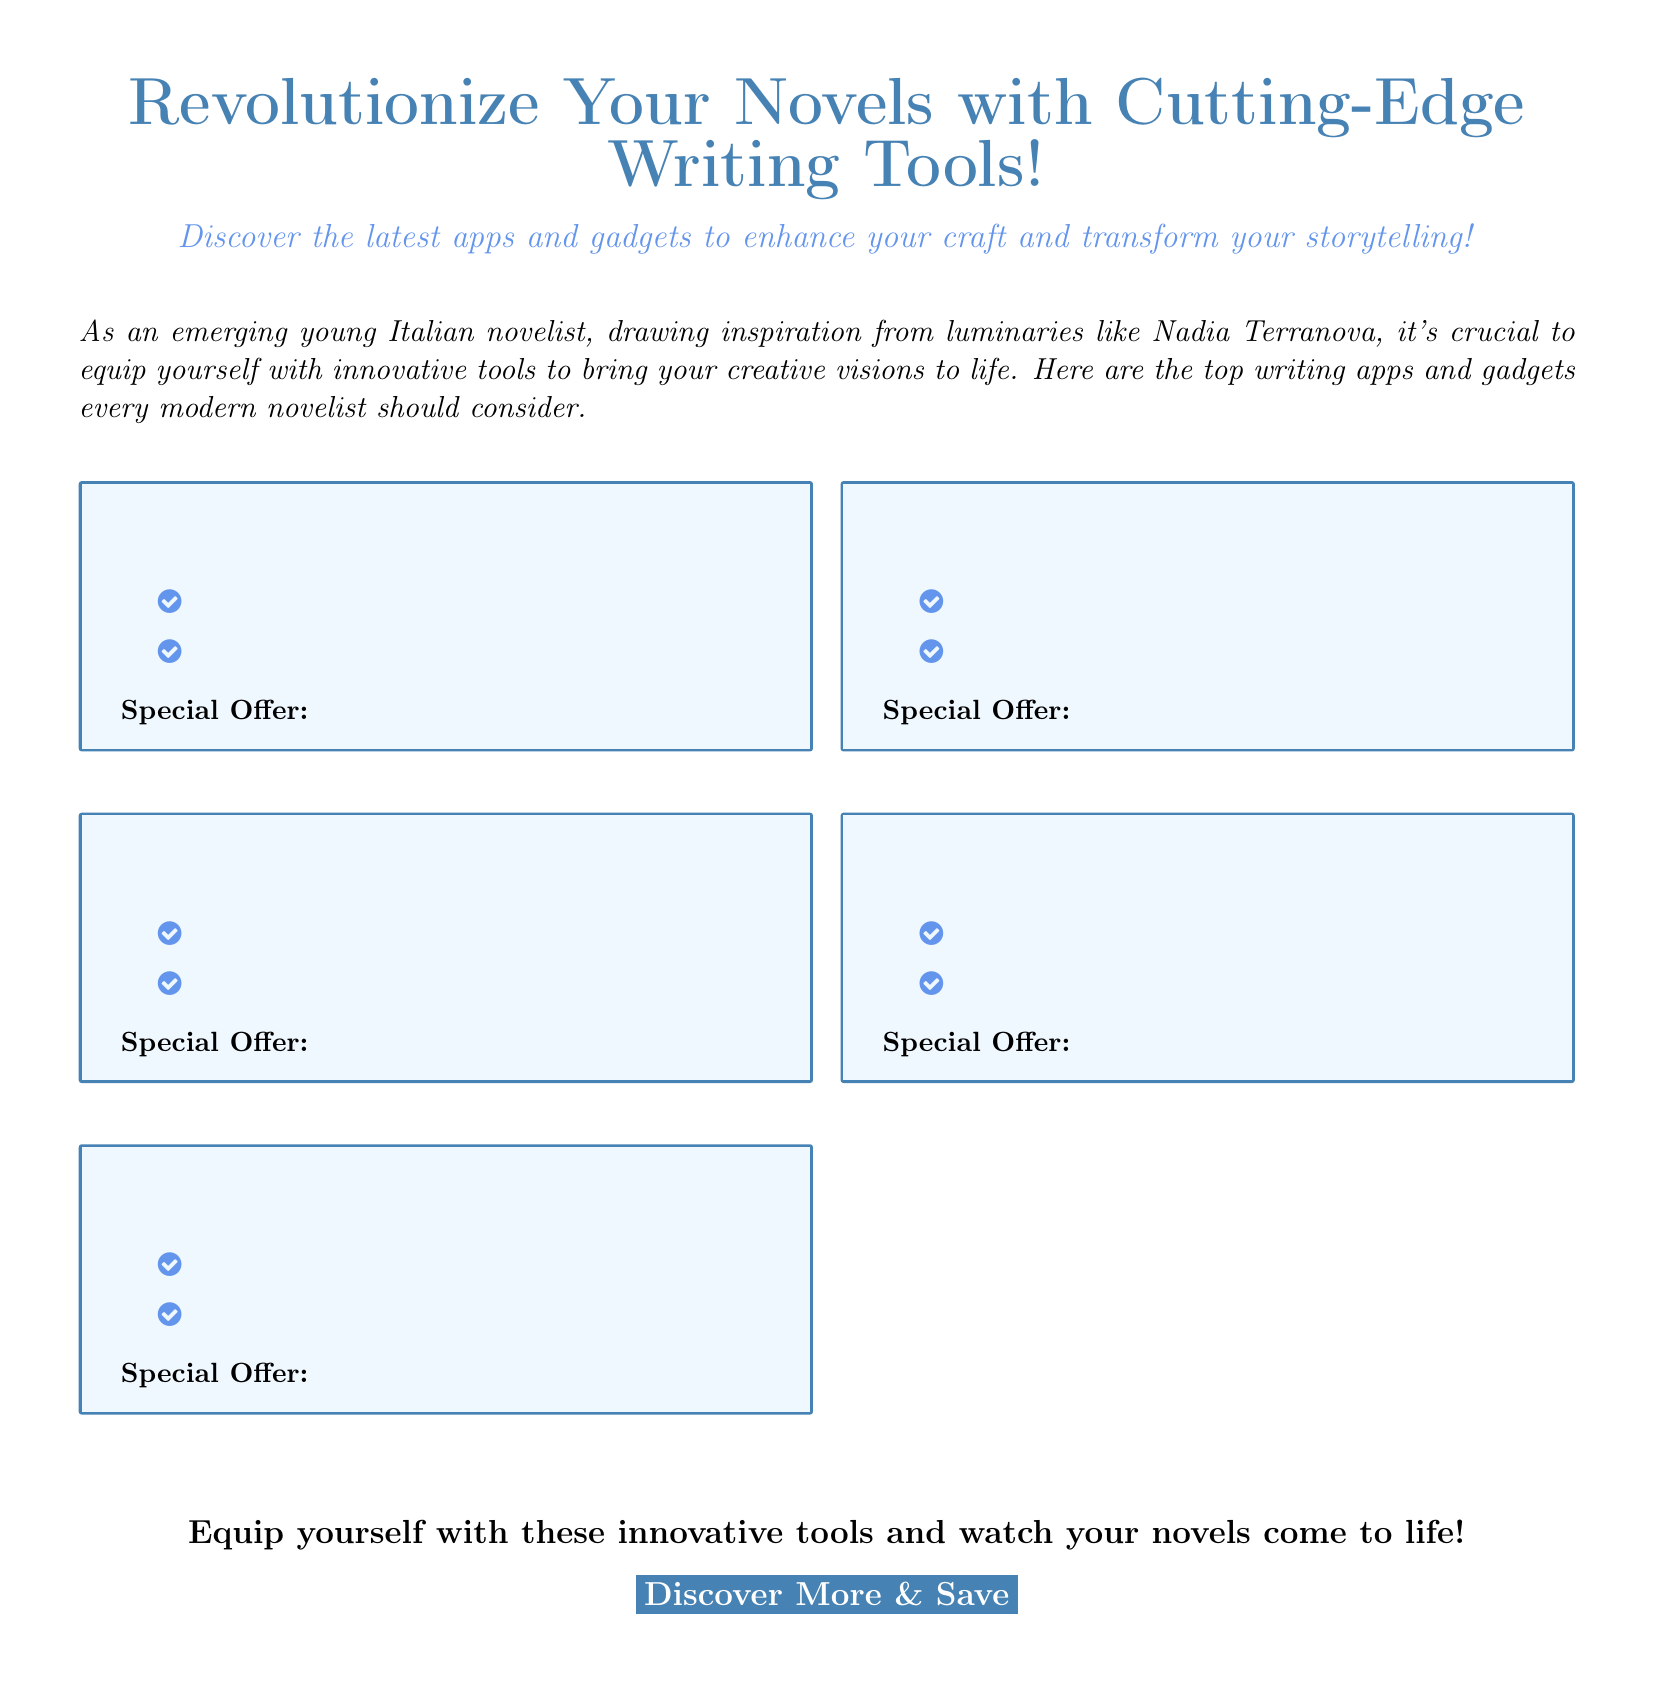What is the main theme of the advertisement? The advertisement promotes innovative writing tools for modern novelists, focusing on apps and gadgets to enhance storytelling.
Answer: Writing tools How many sections are highlighted in the advertisement? The document mentions five sections with specific writing tools highlighted.
Answer: Five What color is used for the header of the advertisement? The header color used in the advertisement is defined as RGB (70,130,180).
Answer: Headcolor What specific benefit do the tools promise to provide to emerging novelists? The tools aim to transform storytelling and enhance the crafting process for novelists.
Answer: Enhance craft What is included in each section of the advertisement? Each section includes a title, description, benefits, and a special offer related to the writing tool.
Answer: Title, description, benefits, special offer How are the benefits of each tool presented in the document? The benefits of each tool are presented in a bulleted list, highlighted with a check circle icon.
Answer: Bulleted list What type of special offer is mentioned for the writing tools? Each of the highlighted writing tools comes with a special offer that is briefly described.
Answer: Special offer What is the page layout style of the advertisement? The advertisement uses a simple layout style with two columns for presenting the information.
Answer: Two-column layout 